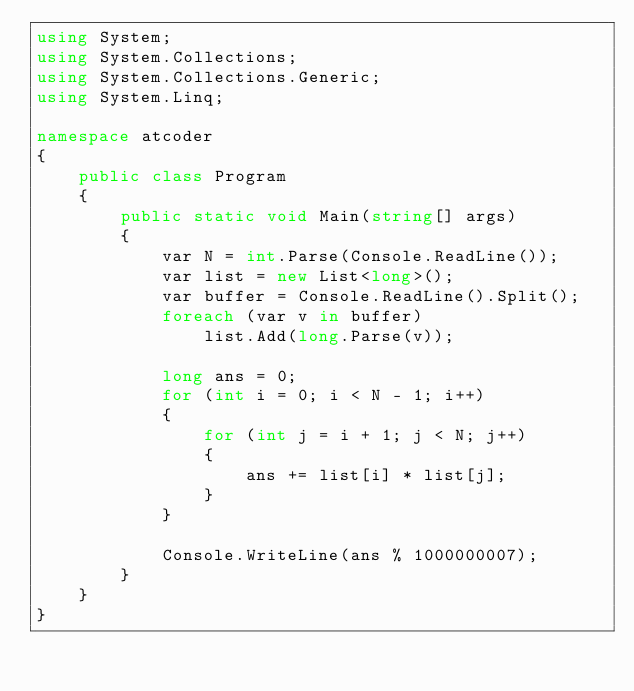Convert code to text. <code><loc_0><loc_0><loc_500><loc_500><_C#_>using System;
using System.Collections;
using System.Collections.Generic;
using System.Linq;

namespace atcoder
{
    public class Program
    {
        public static void Main(string[] args)
        {
            var N = int.Parse(Console.ReadLine());
            var list = new List<long>();
            var buffer = Console.ReadLine().Split();
            foreach (var v in buffer)
                list.Add(long.Parse(v));

            long ans = 0;
            for (int i = 0; i < N - 1; i++)
            {
                for (int j = i + 1; j < N; j++)
                {
                    ans += list[i] * list[j];
                }
            }

            Console.WriteLine(ans % 1000000007);
        }
    }
}
</code> 